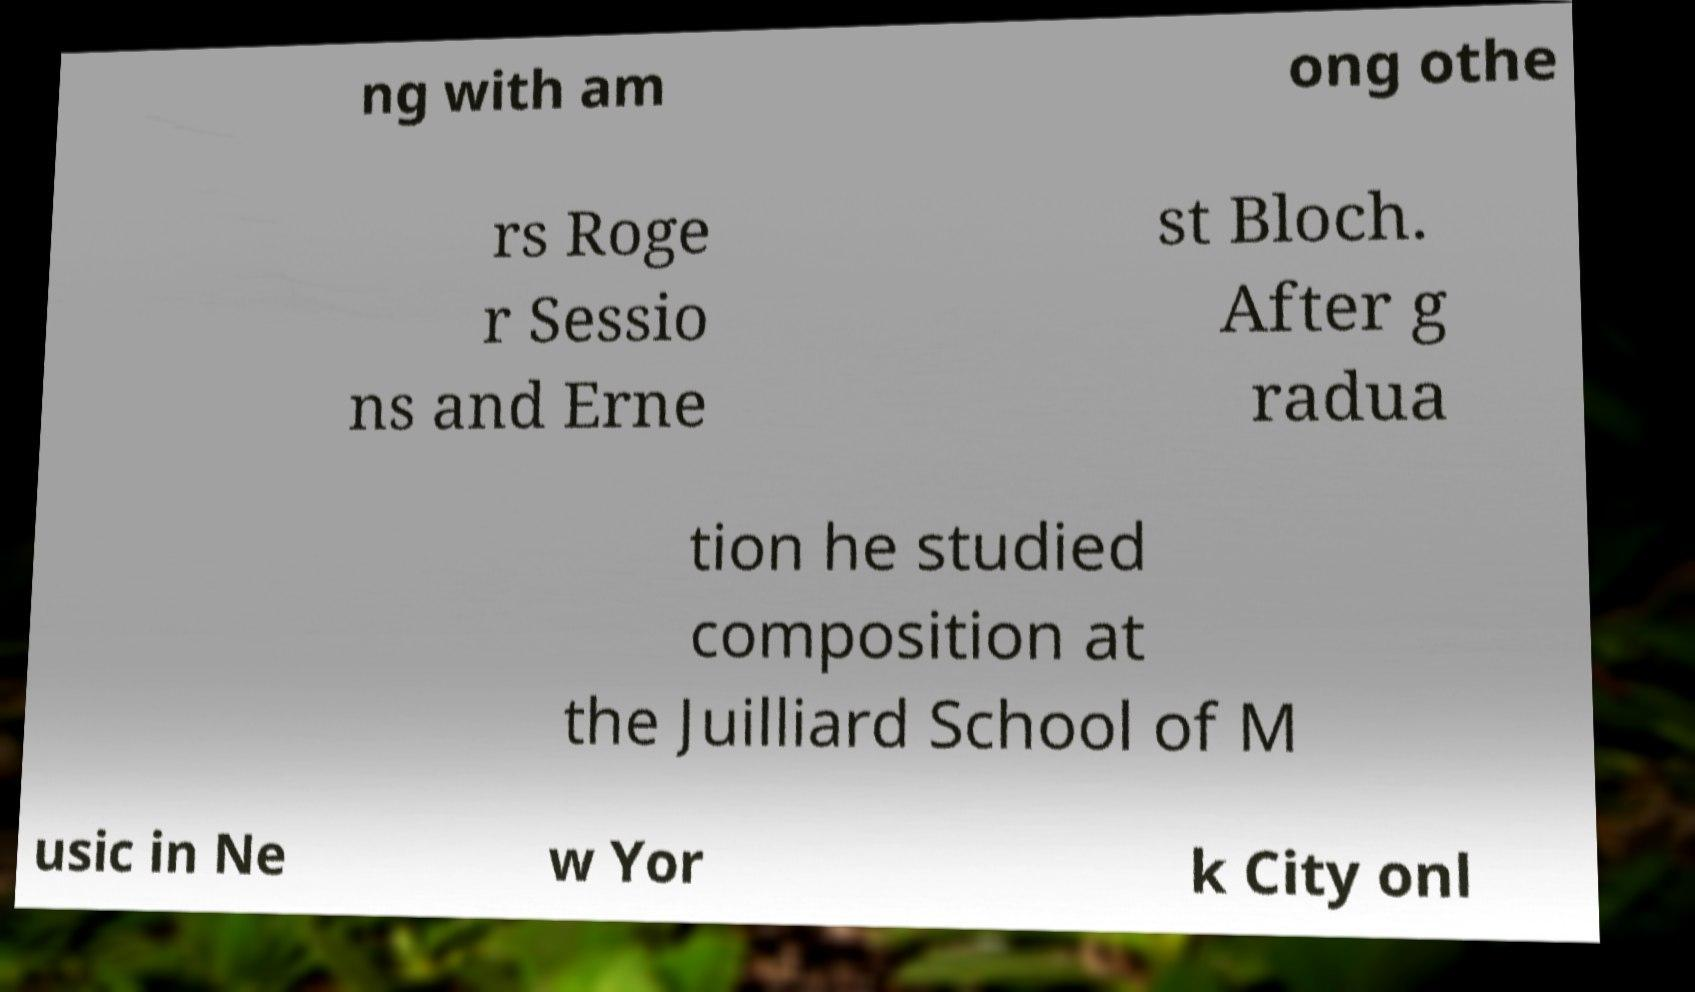Can you accurately transcribe the text from the provided image for me? ng with am ong othe rs Roge r Sessio ns and Erne st Bloch. After g radua tion he studied composition at the Juilliard School of M usic in Ne w Yor k City onl 